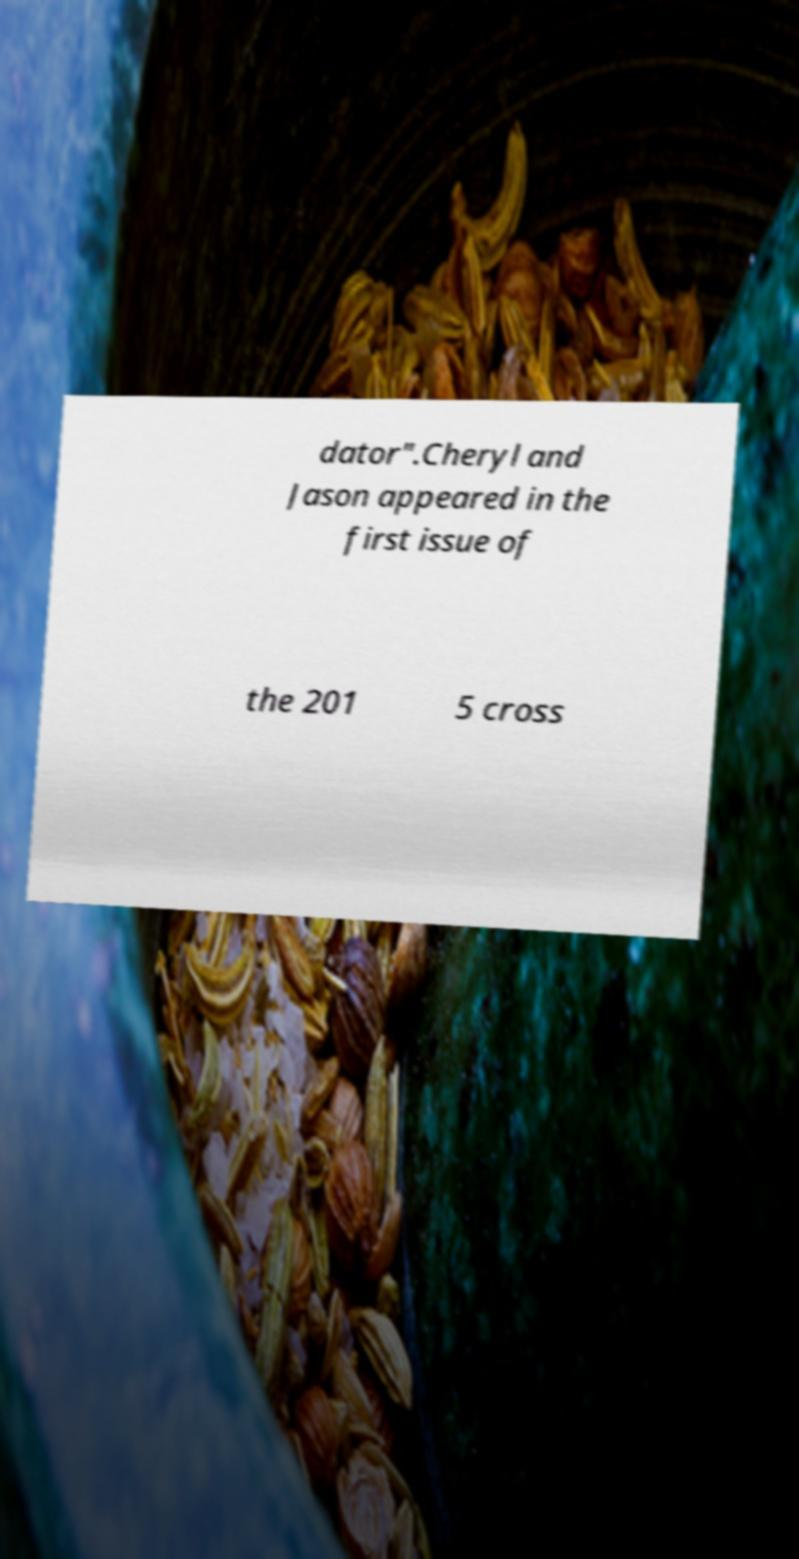What messages or text are displayed in this image? I need them in a readable, typed format. dator".Cheryl and Jason appeared in the first issue of the 201 5 cross 